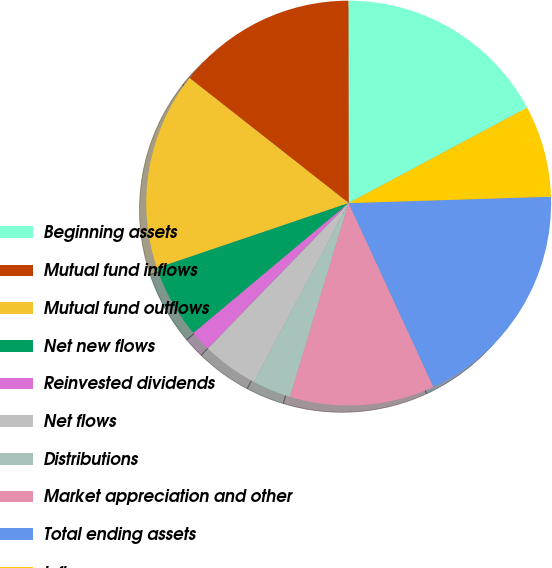Convert chart to OTSL. <chart><loc_0><loc_0><loc_500><loc_500><pie_chart><fcel>Beginning assets<fcel>Mutual fund inflows<fcel>Mutual fund outflows<fcel>Net new flows<fcel>Reinvested dividends<fcel>Net flows<fcel>Distributions<fcel>Market appreciation and other<fcel>Total ending assets<fcel>Inflows<nl><fcel>17.21%<fcel>14.38%<fcel>15.8%<fcel>5.9%<fcel>1.66%<fcel>4.49%<fcel>3.07%<fcel>11.56%<fcel>18.63%<fcel>7.31%<nl></chart> 